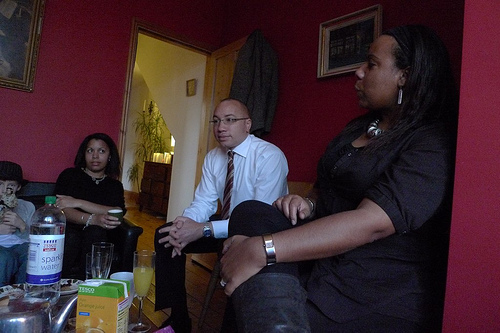<image>Is the bamboo plant in the next room live? It is uncertain if the bamboo plant in the next room is alive. Is the bamboo plant in the next room live? I don't know if the bamboo plant in the next room is live. It can be both live or not. 